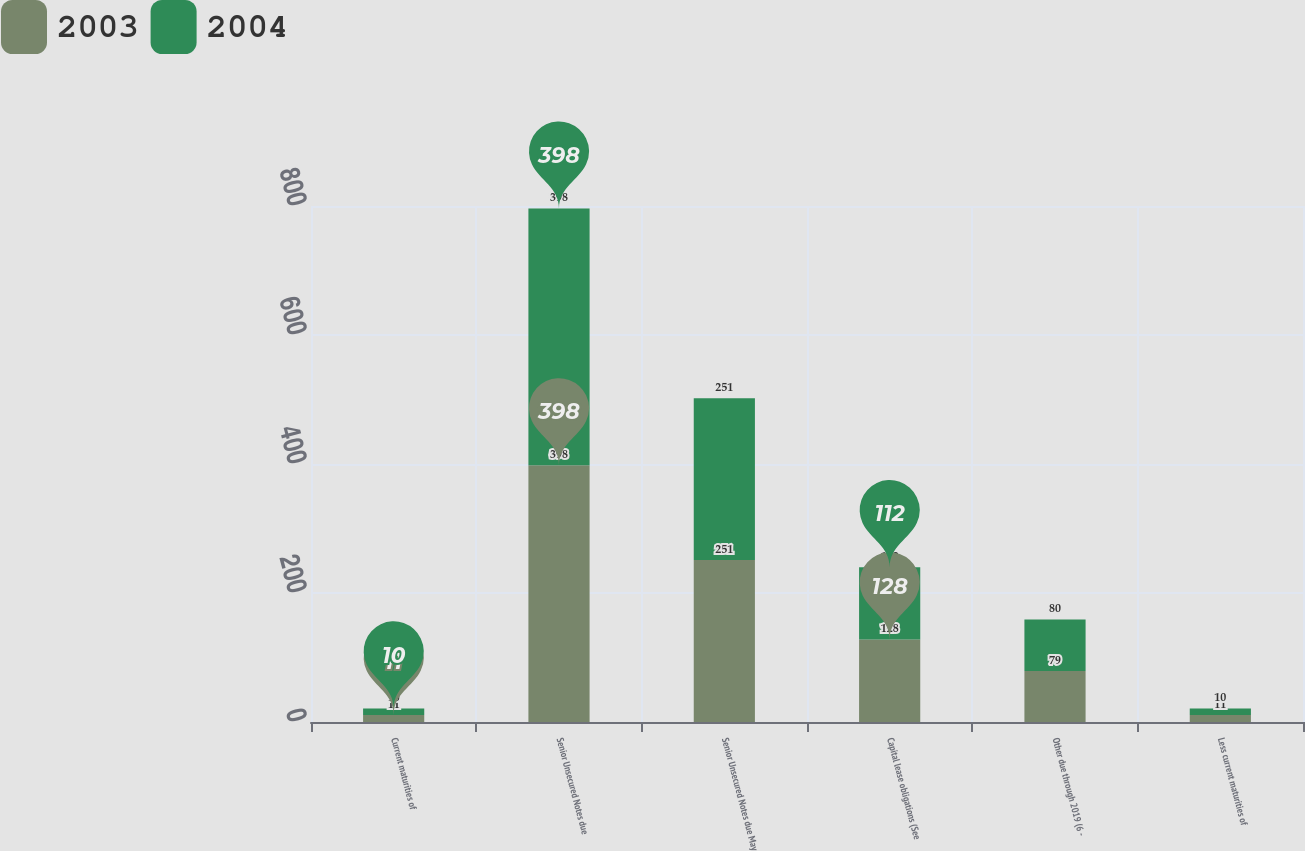Convert chart to OTSL. <chart><loc_0><loc_0><loc_500><loc_500><stacked_bar_chart><ecel><fcel>Current maturities of<fcel>Senior Unsecured Notes due<fcel>Senior Unsecured Notes due May<fcel>Capital lease obligations (See<fcel>Other due through 2019 (6 -<fcel>Less current maturities of<nl><fcel>2003<fcel>11<fcel>398<fcel>251<fcel>128<fcel>79<fcel>11<nl><fcel>2004<fcel>10<fcel>398<fcel>251<fcel>112<fcel>80<fcel>10<nl></chart> 